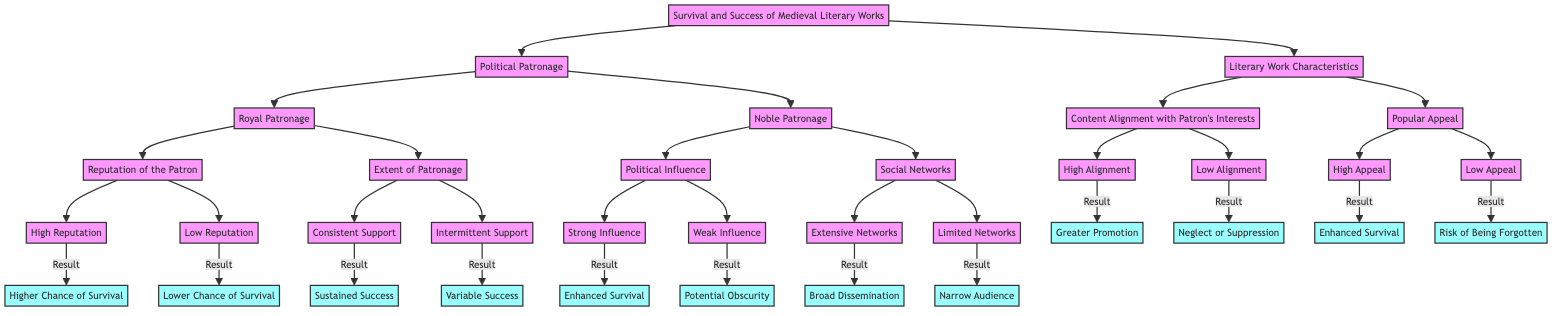What are the two main branches originating from the root? The root node (Survival and Success of Medieval Literary Works) has two primary branches: Political Patronage and Literary Work Characteristics.
Answer: Political Patronage, Literary Work Characteristics Which outcome is associated with High Reputation of the Patron? The diagram shows that High Reputation leads to a higher chance of survival as indicated by the node connected to it.
Answer: Higher Chance of Survival How many nodes are under Royal Patronage? Under the Royal Patronage node, there are two child nodes: Reputation of the Patron and Extent of Patronage, making a total of two nodes.
Answer: 2 What result follows from Strong Influence under Noble Patronage? The outcome associated with Strong Influence is Enhanced Survival, which connects to that specific node in the diagram.
Answer: Enhanced Survival Which type of support leads to Sustained Success? The node labeled Consistent Support under the Extent of Patronage indicates that it leads to Sustained Success as per the flow of the diagram.
Answer: Sustained Success What is the relationship between Political Patronage and Literary Work Characteristics? Political Patronage and Literary Work Characteristics are two separate main branches that stem from the root, indicating that both factors are crucial but distinct aspects influencing the success of medieval literary works.
Answer: Distinct Aspects What leads to Narrow Audience in the context of Social Networks? Limited Networks under Social Networks directly links to the outcome Narrow Audience, showing the impact of limited social connections on dissemination.
Answer: Narrow Audience What does Low Alignment with Patron's Interests lead to? The diagram indicates that Low Alignment with Patron's Interests results in Neglect or Suppression as stated under Content Alignment with Patron's Interests.
Answer: Neglect or Suppression If a literary work has High Appeal, what is its outcome? High Appeal leads to Enhanced Survival according to the connection indicated in the Popular Appeal node.
Answer: Enhanced Survival 